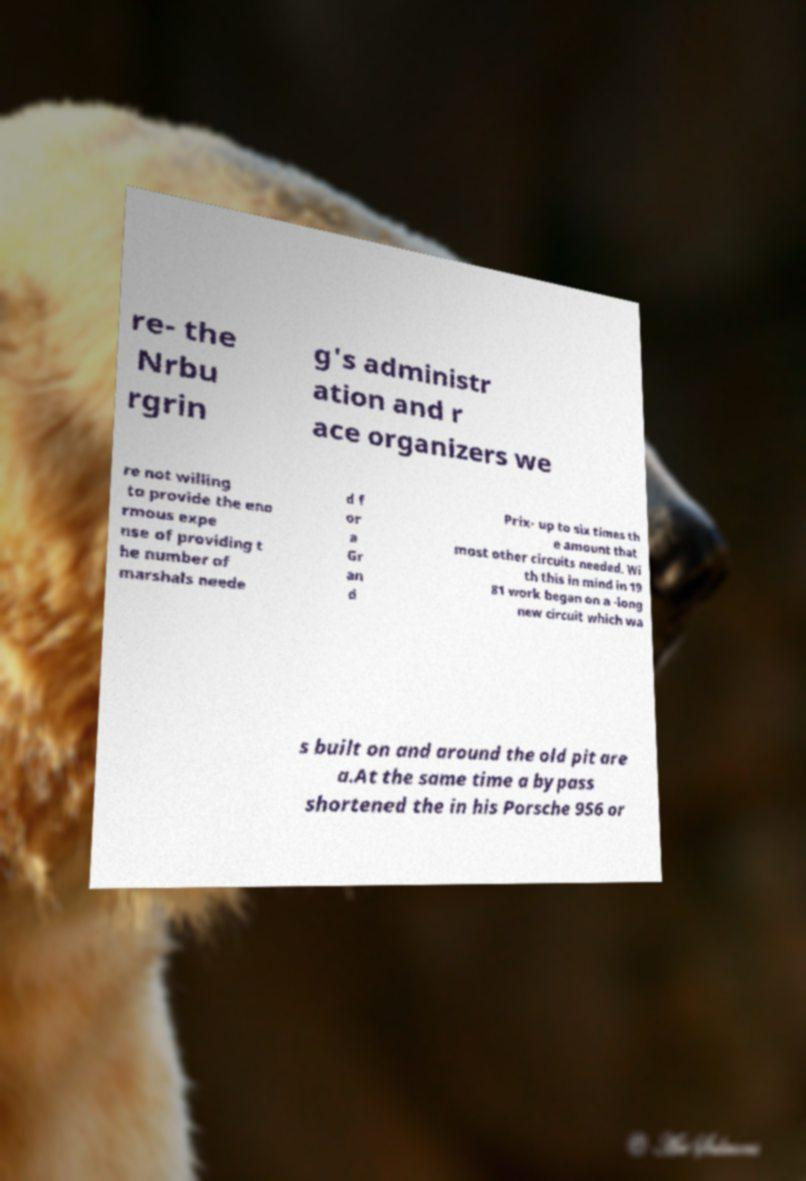Can you read and provide the text displayed in the image?This photo seems to have some interesting text. Can you extract and type it out for me? re- the Nrbu rgrin g's administr ation and r ace organizers we re not willing to provide the eno rmous expe nse of providing t he number of marshals neede d f or a Gr an d Prix- up to six times th e amount that most other circuits needed. Wi th this in mind in 19 81 work began on a -long new circuit which wa s built on and around the old pit are a.At the same time a bypass shortened the in his Porsche 956 or 